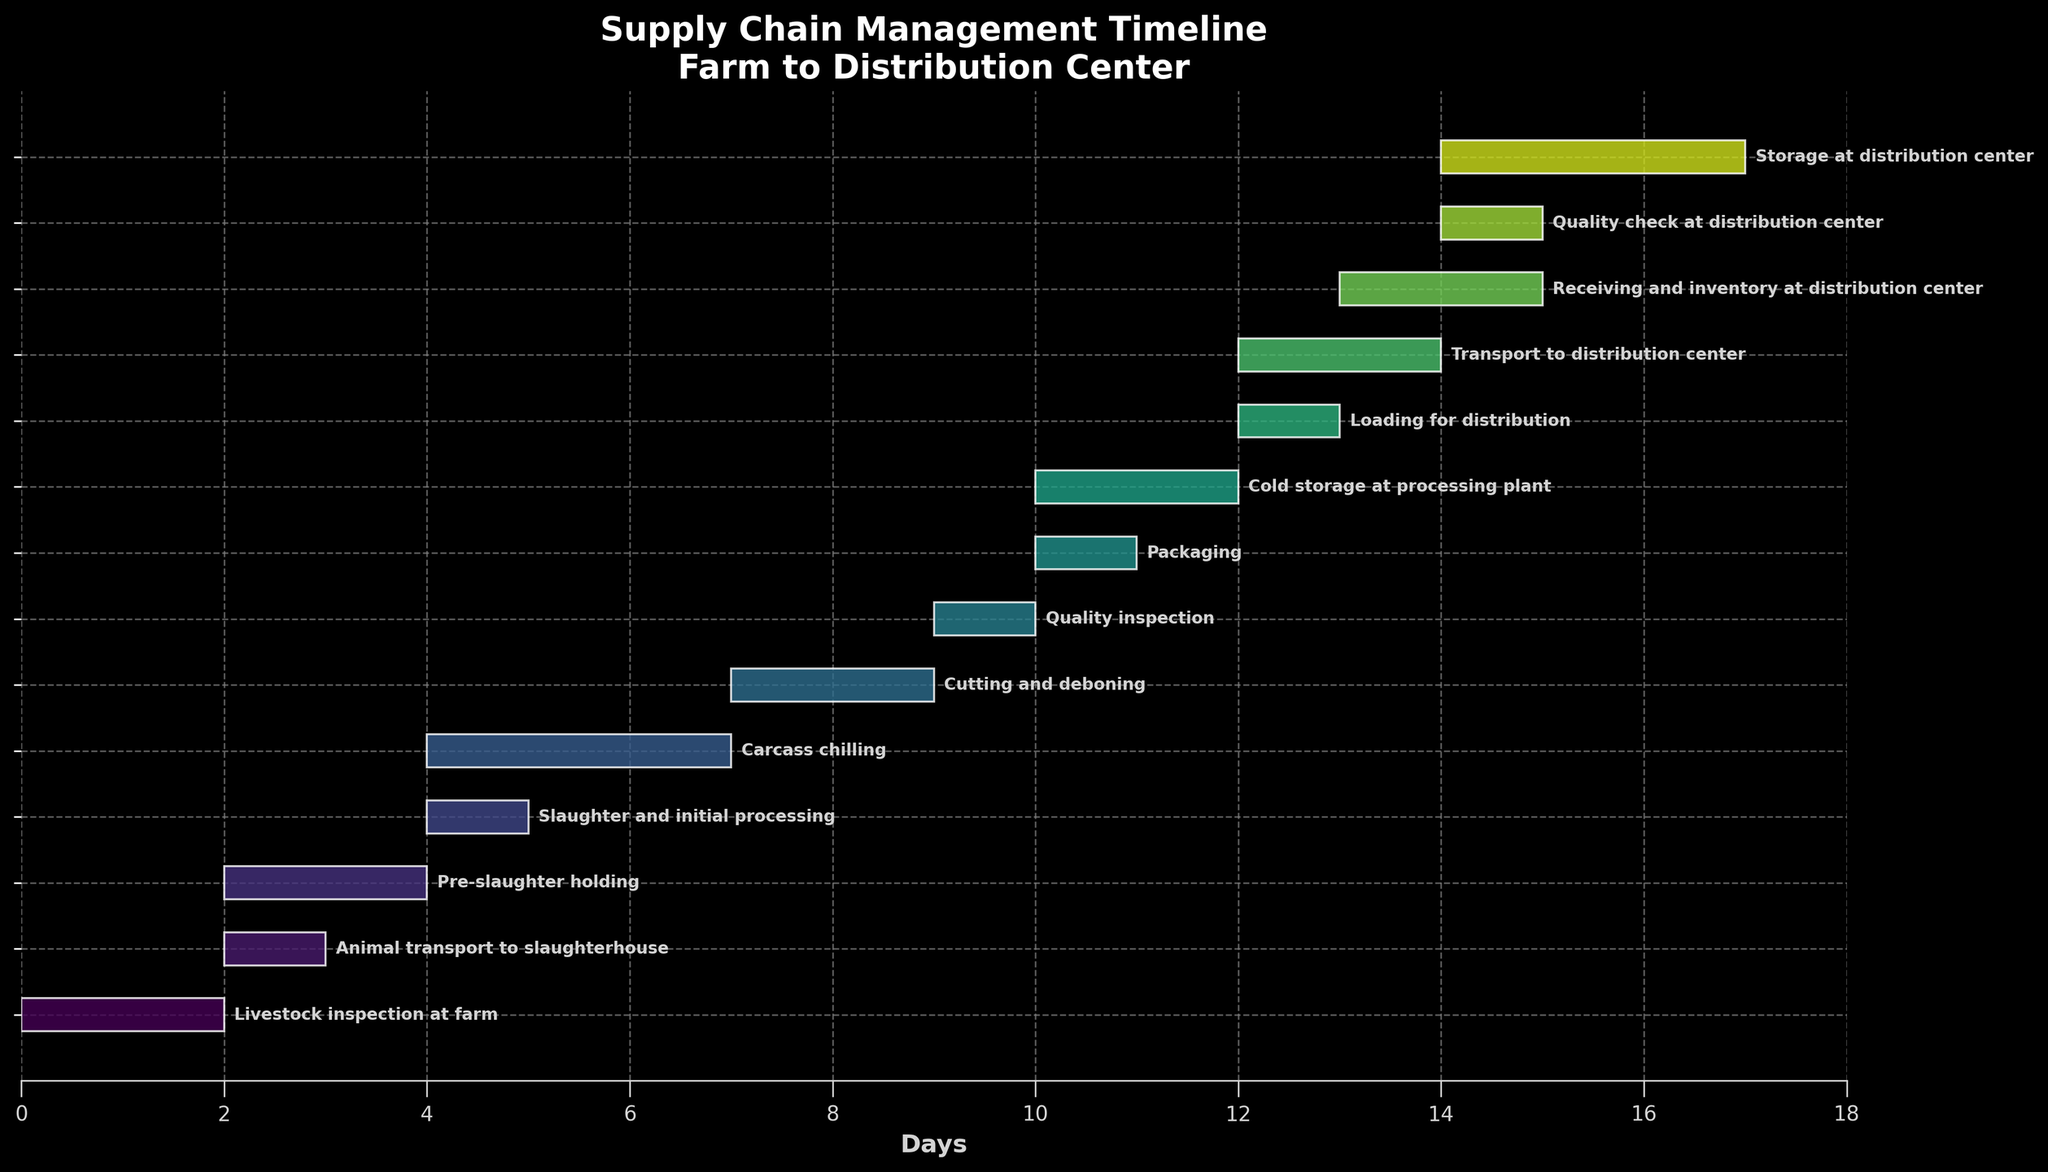Which task is the first in the supply chain management timeline? The first task in the supply chain timeline is the one that starts on Day 1. According to the figure, "Livestock inspection at farm" is the task that starts on Day 1.
Answer: Livestock inspection at farm How many days does the "Carcass chilling" process take? The "Carcass chilling" process starts on Day 5 and ends on Day 7. To calculate the duration, subtract Day 5 from Day 7 and add 1: (7 - 5) + 1.
Answer: 3 days Which activity lasts the longest, and how long is it? To determine which activity lasts the longest, compare the duration of all activities. "Carcass chilling" starts on Day 5 and ends on Day 7, which is 3 days. No other task lasts longer than 3 days.
Answer: Carcass chilling, 3 days How many tasks are completed by Day 7? Tasks completed by Day 7 are those whose end date is on or before Day 7. Referring to the figure, the tasks are "Livestock inspection at farm," "Animal transport to slaughterhouse," "Pre-slaughter holding," "Slaughter and initial processing," and "Carcass chilling."
Answer: 5 tasks What is the last task in the supply chain management timeline? The last task in the timeline is the one that ends on the latest day. According to the figure, "Storage at distribution center" ends on Day 17.
Answer: Storage at distribution center Which tasks occur on Day 13? To find out which tasks occur on Day 13, look for tasks that start, end, or occur within that day. The tasks are "Loading for distribution" (starts and ends on Day 13) and "Transport to distribution center" (starts on Day 13 and ends on Day 14).
Answer: Loading for distribution, Transport to distribution center Which task directly precedes "Cutting and deboning"? The task that directly precedes "Cutting and deboning" should end before Day 8. According to the figure, the "Carcass chilling" process ends on Day 7, and "Cutting and deboning" starts on Day 8.
Answer: Carcass chilling How many tasks involve a quality check or inspection? Tasks that involve "inspection" or "quality check" are "Livestock inspection at farm," "Quality inspection," and "Quality check at distribution center."
Answer: 3 tasks What is the total duration from the first to the last task in the timeline? The duration from the first task to the last task is calculated from the start of the first task ("Livestock inspection at farm" on Day 1) to the end of the last task ("Storage at distribution center" on Day 17). The total duration is from Day 1 to Day 17.
Answer: 17 days 